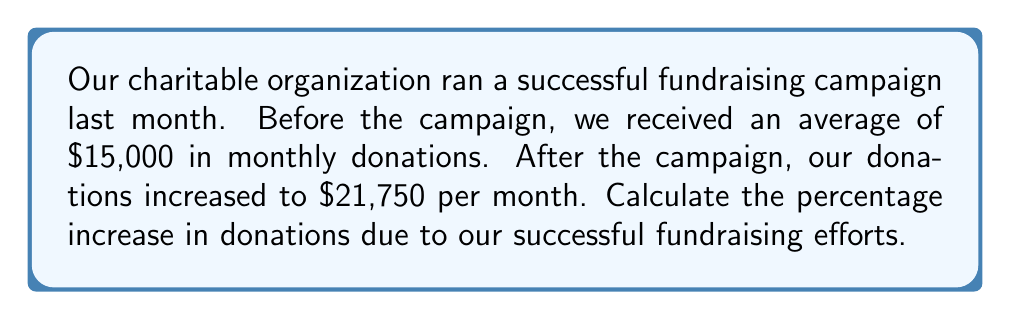What is the answer to this math problem? To calculate the percentage increase in donations, we need to follow these steps:

1. Calculate the difference between the new and original donation amounts:
   $\text{Increase} = \text{New amount} - \text{Original amount}$
   $\text{Increase} = \$21,750 - \$15,000 = \$6,750$

2. Divide the increase by the original amount:
   $\text{Fraction of increase} = \frac{\text{Increase}}{\text{Original amount}}$
   $\text{Fraction of increase} = \frac{\$6,750}{\$15,000} = 0.45$

3. Convert the fraction to a percentage by multiplying by 100:
   $\text{Percentage increase} = \text{Fraction of increase} \times 100\%$
   $\text{Percentage increase} = 0.45 \times 100\% = 45\%$

Therefore, the percentage increase in donations after our successful fundraising campaign is 45%.

This significant increase demonstrates the effectiveness of our campaign and the growing support for our charitable organization.
Answer: 45% 